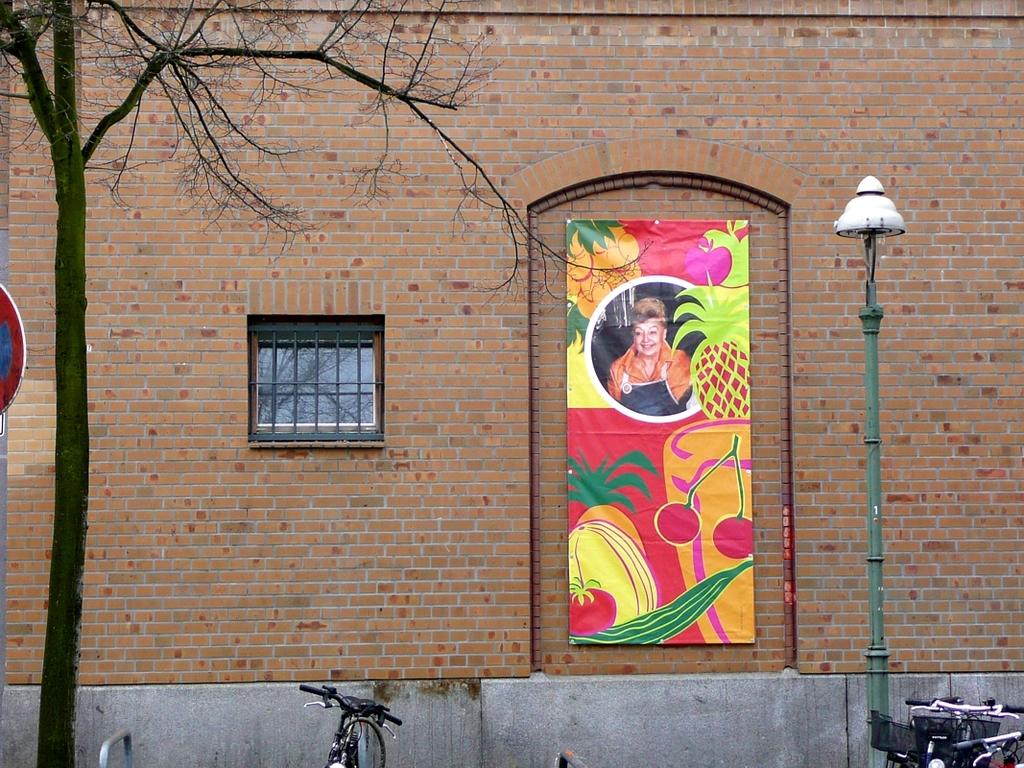What type of vehicles are at the bottom of the image? There are bicycles at the bottom of the image. What is located behind the bicycles? There is a pole behind the bicycles. What is situated behind the pole? There is a tree behind the pole. What can be seen behind the tree? There is a sign board behind the tree. What is positioned behind the sign board? There is a building behind the sign board. What is on the building in the image? There is a banner on the building. How much debt is the cow carrying in the image? There is no cow present in the image, and therefore no debt can be associated with it. 